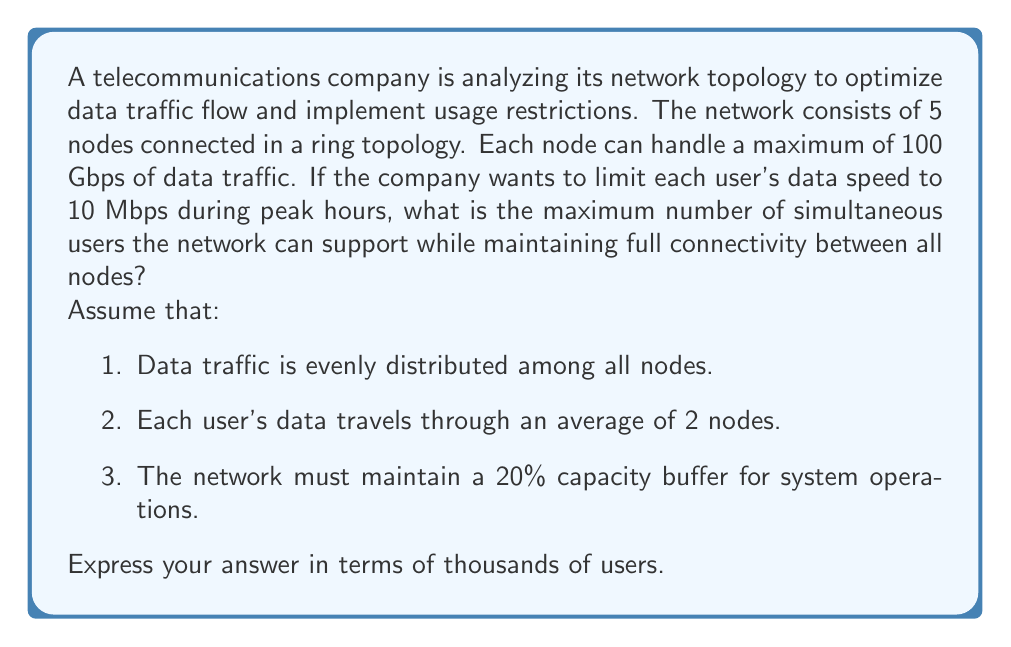Give your solution to this math problem. Let's approach this problem step-by-step:

1) First, we need to calculate the total network capacity:
   $$\text{Total Capacity} = 5 \text{ nodes} \times 100 \text{ Gbps} = 500 \text{ Gbps}$$

2) We need to account for the 20% capacity buffer:
   $$\text{Available Capacity} = 500 \text{ Gbps} \times 0.8 = 400 \text{ Gbps}$$

3) Convert available capacity to Mbps:
   $$400 \text{ Gbps} = 400,000 \text{ Mbps}$$

4) Each user requires 10 Mbps, but their data travels through an average of 2 nodes:
   $$\text{Effective user requirement} = 10 \text{ Mbps} \times 2 = 20 \text{ Mbps}$$

5) Calculate the number of users:
   $$\text{Number of users} = \frac{\text{Available Capacity}}{\text{Effective user requirement}}$$
   $$= \frac{400,000 \text{ Mbps}}{20 \text{ Mbps}} = 20,000 \text{ users}$$

6) Express the result in thousands of users:
   $$20,000 \text{ users} = 20 \text{ thousand users}$$
Answer: 20 thousand users 